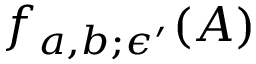Convert formula to latex. <formula><loc_0><loc_0><loc_500><loc_500>f _ { a , b ; \epsilon ^ { \prime } } ( A )</formula> 